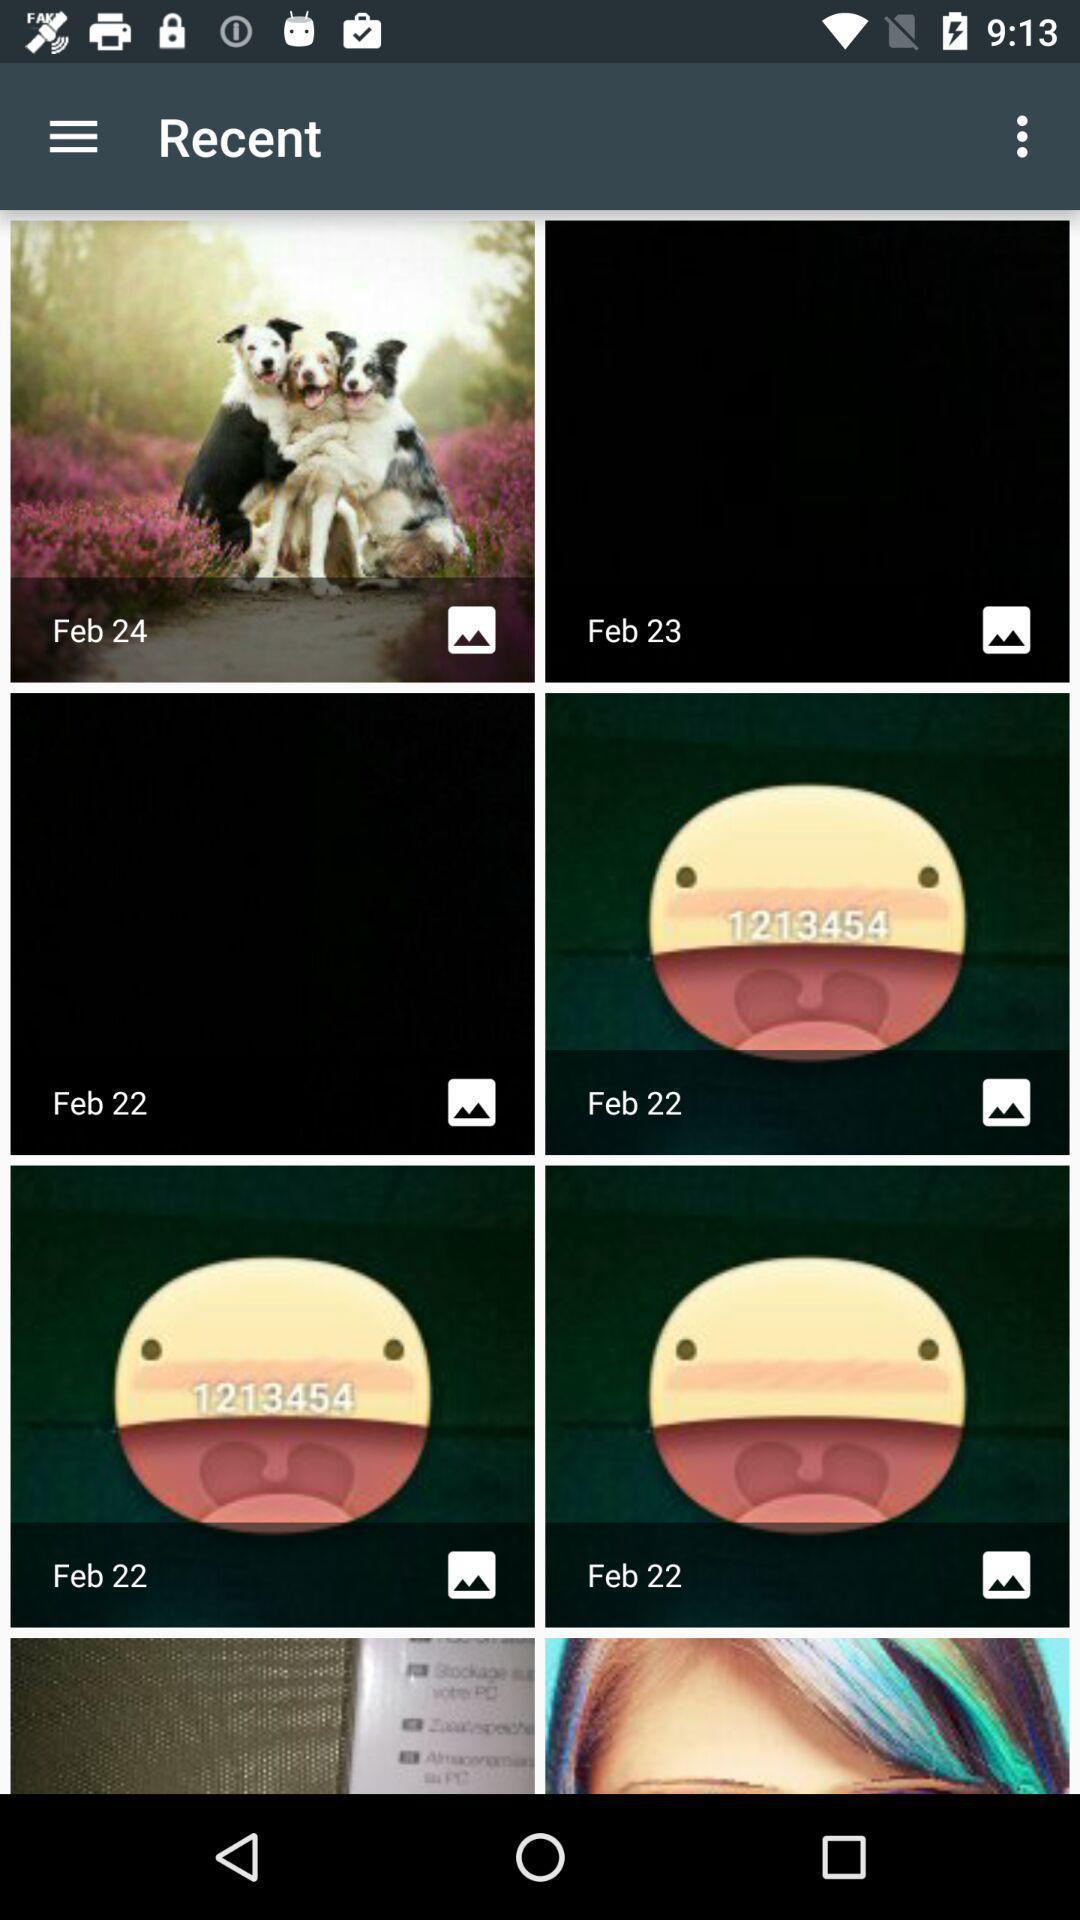Provide a textual representation of this image. Screen displaying the various images in recent tab. 